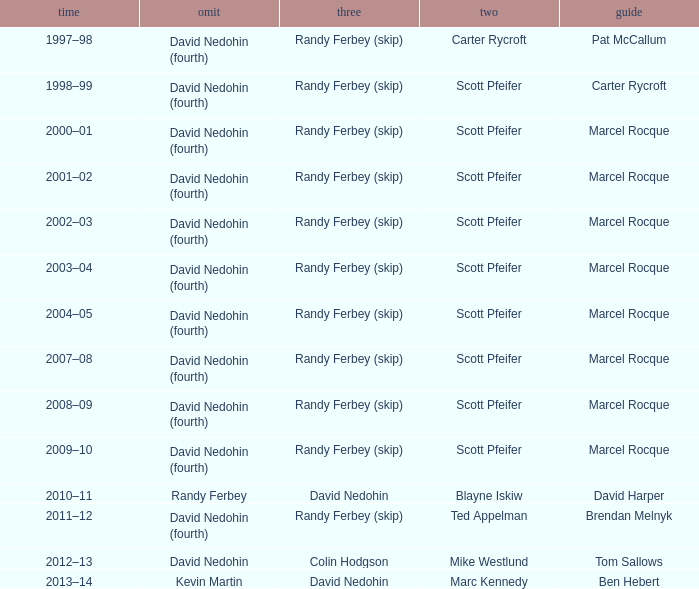Which Season has a Third of colin hodgson? 2012–13. 